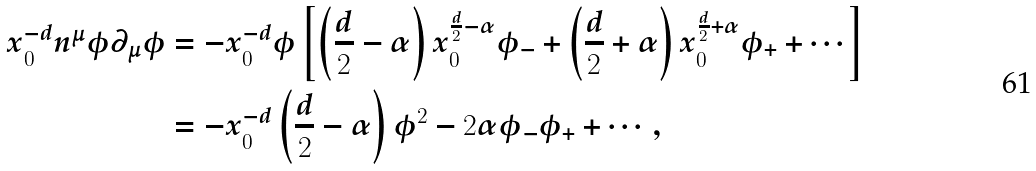<formula> <loc_0><loc_0><loc_500><loc_500>x _ { 0 } ^ { - d } n ^ { \mu } \phi \partial _ { \mu } \phi & = - x _ { 0 } ^ { - d } \phi \left [ \left ( \frac { d } 2 - \alpha \right ) x _ { 0 } ^ { \frac { d } 2 - \alpha } \phi _ { - } + \left ( \frac { d } 2 + \alpha \right ) x _ { 0 } ^ { \frac { d } 2 + \alpha } \phi _ { + } + \cdots \right ] \\ & = - x _ { 0 } ^ { - d } \left ( \frac { d } 2 - \alpha \right ) \phi ^ { 2 } - 2 \alpha \phi _ { - } \phi _ { + } + \cdots ,</formula> 